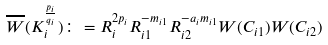Convert formula to latex. <formula><loc_0><loc_0><loc_500><loc_500>\overline { W } ( K _ { i } ^ { \frac { p _ { i } } { q _ { i } } } ) \colon = R _ { i } ^ { 2 p _ { i } } R _ { i 1 } ^ { - m _ { i 1 } } R _ { i 2 } ^ { - a _ { i } m _ { i 1 } } W ( C _ { i 1 } ) W ( C _ { i 2 } )</formula> 